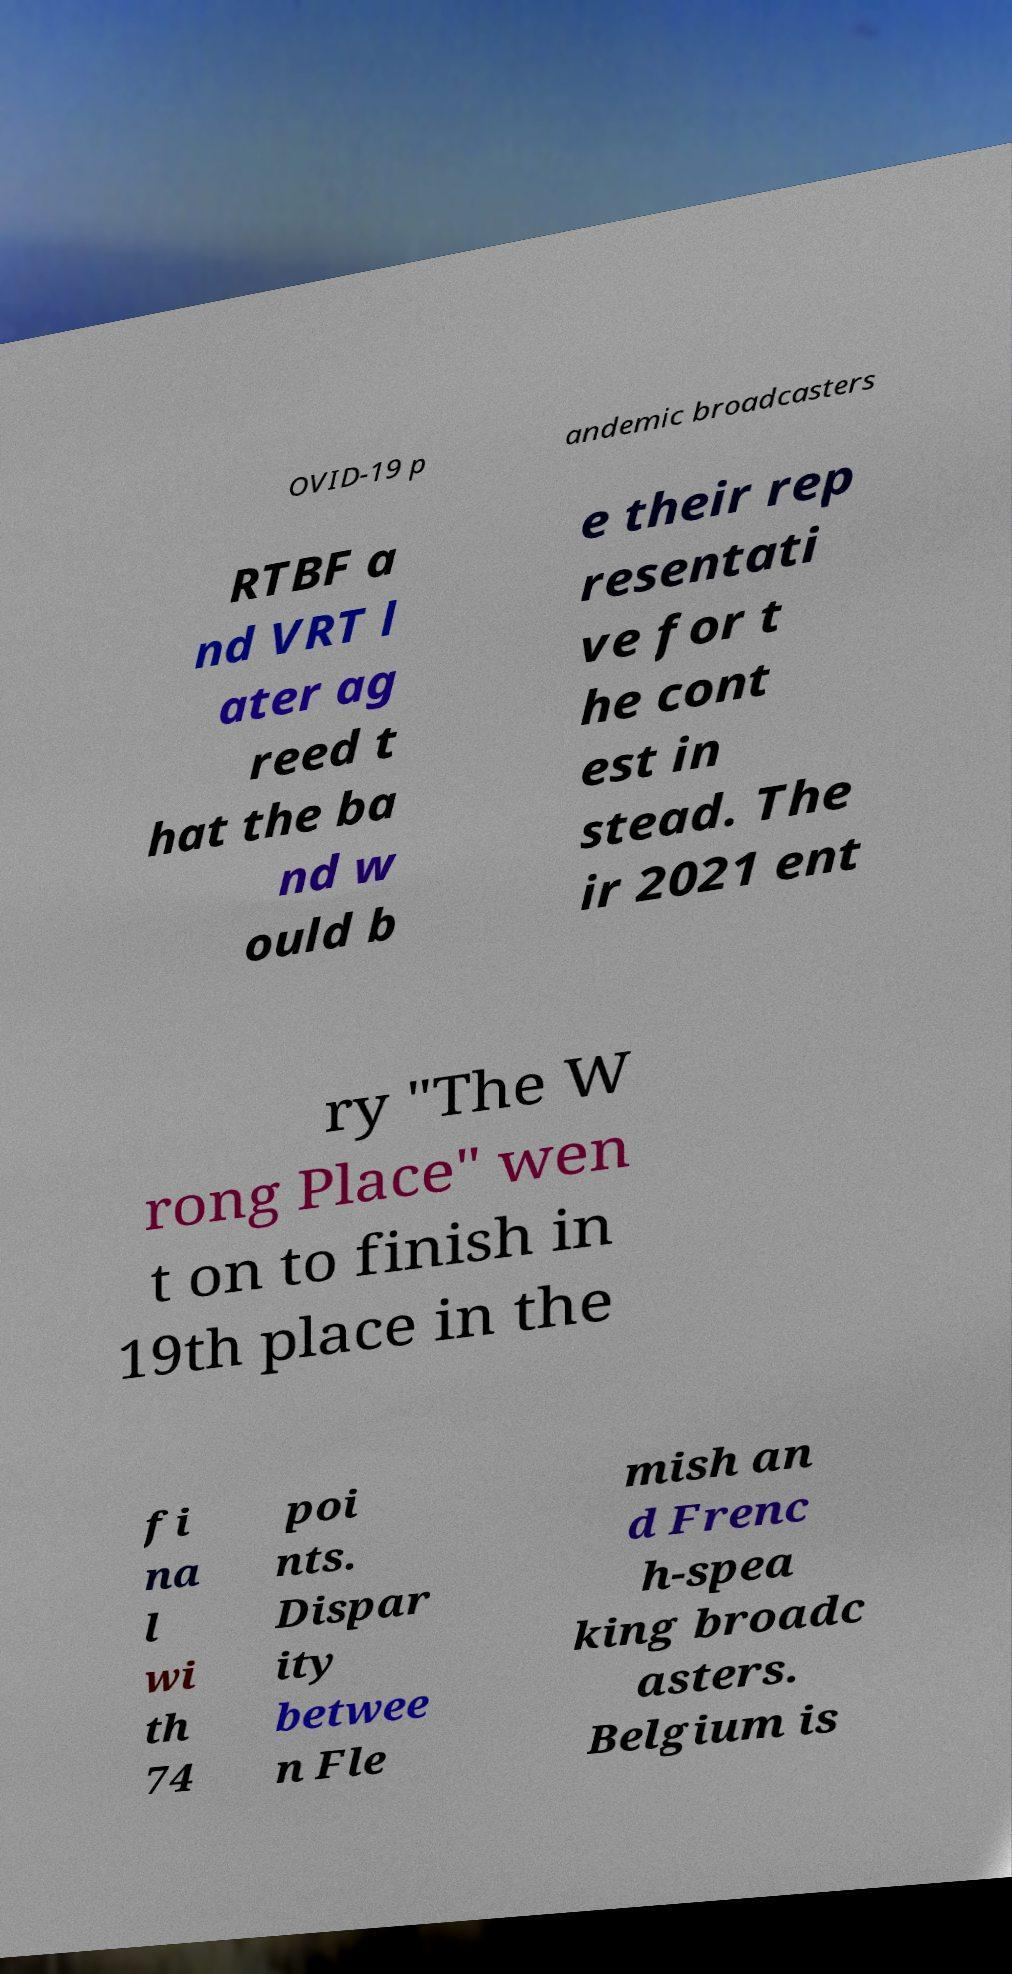What messages or text are displayed in this image? I need them in a readable, typed format. OVID-19 p andemic broadcasters RTBF a nd VRT l ater ag reed t hat the ba nd w ould b e their rep resentati ve for t he cont est in stead. The ir 2021 ent ry "The W rong Place" wen t on to finish in 19th place in the fi na l wi th 74 poi nts. Dispar ity betwee n Fle mish an d Frenc h-spea king broadc asters. Belgium is 